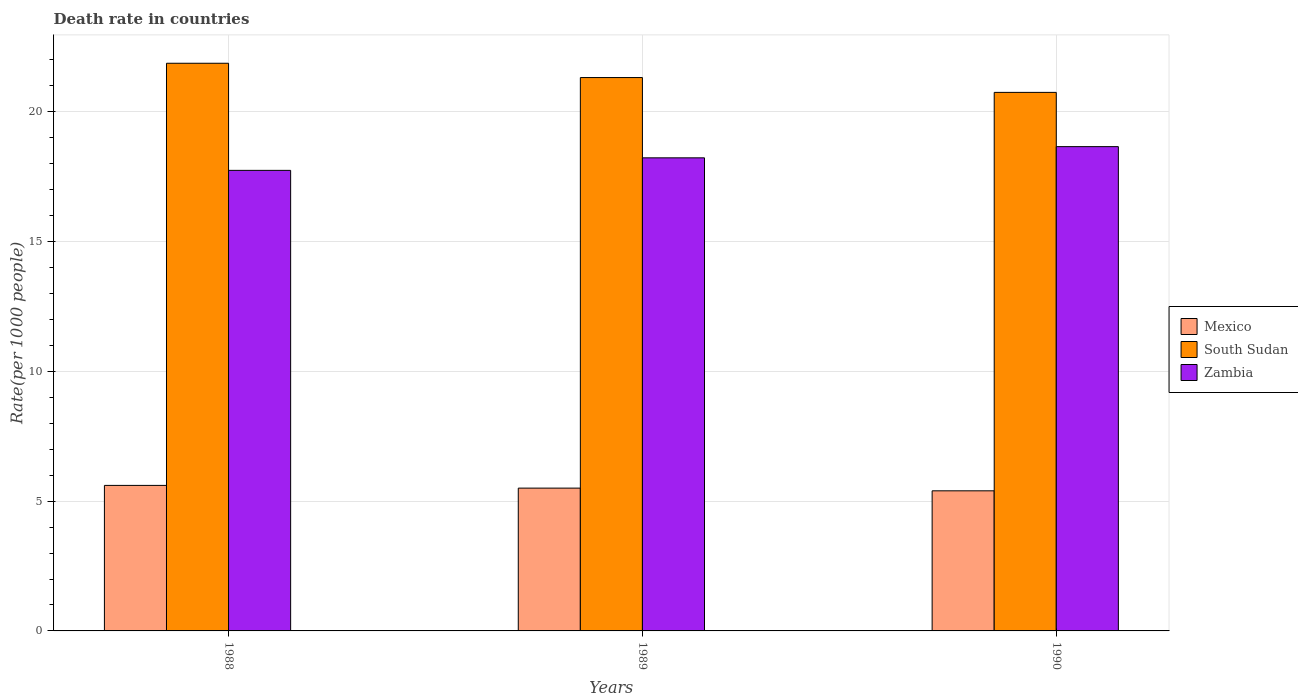Are the number of bars on each tick of the X-axis equal?
Your answer should be very brief. Yes. How many bars are there on the 3rd tick from the left?
Your answer should be compact. 3. What is the label of the 2nd group of bars from the left?
Provide a succinct answer. 1989. In how many cases, is the number of bars for a given year not equal to the number of legend labels?
Provide a succinct answer. 0. What is the death rate in South Sudan in 1990?
Give a very brief answer. 20.75. Across all years, what is the maximum death rate in Zambia?
Offer a terse response. 18.66. Across all years, what is the minimum death rate in Zambia?
Provide a succinct answer. 17.74. In which year was the death rate in Mexico minimum?
Provide a succinct answer. 1990. What is the total death rate in Mexico in the graph?
Offer a terse response. 16.51. What is the difference between the death rate in Zambia in 1988 and that in 1989?
Your response must be concise. -0.48. What is the difference between the death rate in Zambia in 1989 and the death rate in South Sudan in 1990?
Provide a short and direct response. -2.52. What is the average death rate in South Sudan per year?
Provide a succinct answer. 21.31. In the year 1989, what is the difference between the death rate in South Sudan and death rate in Mexico?
Your response must be concise. 15.82. What is the ratio of the death rate in South Sudan in 1988 to that in 1989?
Your answer should be very brief. 1.03. Is the death rate in South Sudan in 1989 less than that in 1990?
Offer a very short reply. No. Is the difference between the death rate in South Sudan in 1988 and 1990 greater than the difference between the death rate in Mexico in 1988 and 1990?
Make the answer very short. Yes. What is the difference between the highest and the second highest death rate in South Sudan?
Your answer should be compact. 0.55. What is the difference between the highest and the lowest death rate in Mexico?
Your answer should be compact. 0.21. In how many years, is the death rate in South Sudan greater than the average death rate in South Sudan taken over all years?
Keep it short and to the point. 2. Is the sum of the death rate in Zambia in 1988 and 1989 greater than the maximum death rate in Mexico across all years?
Keep it short and to the point. Yes. What does the 2nd bar from the left in 1988 represents?
Ensure brevity in your answer.  South Sudan. How many bars are there?
Provide a succinct answer. 9. How many years are there in the graph?
Make the answer very short. 3. What is the difference between two consecutive major ticks on the Y-axis?
Make the answer very short. 5. Does the graph contain any zero values?
Provide a succinct answer. No. Does the graph contain grids?
Keep it short and to the point. Yes. How many legend labels are there?
Provide a short and direct response. 3. How are the legend labels stacked?
Make the answer very short. Vertical. What is the title of the graph?
Provide a succinct answer. Death rate in countries. What is the label or title of the X-axis?
Offer a terse response. Years. What is the label or title of the Y-axis?
Give a very brief answer. Rate(per 1000 people). What is the Rate(per 1000 people) of Mexico in 1988?
Provide a short and direct response. 5.61. What is the Rate(per 1000 people) in South Sudan in 1988?
Provide a succinct answer. 21.87. What is the Rate(per 1000 people) of Zambia in 1988?
Provide a succinct answer. 17.74. What is the Rate(per 1000 people) in Mexico in 1989?
Give a very brief answer. 5.5. What is the Rate(per 1000 people) of South Sudan in 1989?
Offer a terse response. 21.32. What is the Rate(per 1000 people) in Zambia in 1989?
Your answer should be compact. 18.23. What is the Rate(per 1000 people) in Mexico in 1990?
Keep it short and to the point. 5.4. What is the Rate(per 1000 people) in South Sudan in 1990?
Your answer should be compact. 20.75. What is the Rate(per 1000 people) in Zambia in 1990?
Offer a terse response. 18.66. Across all years, what is the maximum Rate(per 1000 people) in Mexico?
Your answer should be compact. 5.61. Across all years, what is the maximum Rate(per 1000 people) in South Sudan?
Offer a very short reply. 21.87. Across all years, what is the maximum Rate(per 1000 people) in Zambia?
Give a very brief answer. 18.66. Across all years, what is the minimum Rate(per 1000 people) in Mexico?
Provide a succinct answer. 5.4. Across all years, what is the minimum Rate(per 1000 people) of South Sudan?
Provide a short and direct response. 20.75. Across all years, what is the minimum Rate(per 1000 people) in Zambia?
Offer a terse response. 17.74. What is the total Rate(per 1000 people) in Mexico in the graph?
Ensure brevity in your answer.  16.51. What is the total Rate(per 1000 people) in South Sudan in the graph?
Your answer should be compact. 63.94. What is the total Rate(per 1000 people) in Zambia in the graph?
Make the answer very short. 54.63. What is the difference between the Rate(per 1000 people) in Mexico in 1988 and that in 1989?
Your response must be concise. 0.1. What is the difference between the Rate(per 1000 people) in South Sudan in 1988 and that in 1989?
Keep it short and to the point. 0.55. What is the difference between the Rate(per 1000 people) of Zambia in 1988 and that in 1989?
Give a very brief answer. -0.48. What is the difference between the Rate(per 1000 people) in Mexico in 1988 and that in 1990?
Provide a short and direct response. 0.21. What is the difference between the Rate(per 1000 people) of South Sudan in 1988 and that in 1990?
Your answer should be very brief. 1.12. What is the difference between the Rate(per 1000 people) of Zambia in 1988 and that in 1990?
Your response must be concise. -0.92. What is the difference between the Rate(per 1000 people) in Mexico in 1989 and that in 1990?
Offer a terse response. 0.1. What is the difference between the Rate(per 1000 people) of South Sudan in 1989 and that in 1990?
Provide a succinct answer. 0.57. What is the difference between the Rate(per 1000 people) of Zambia in 1989 and that in 1990?
Offer a terse response. -0.43. What is the difference between the Rate(per 1000 people) in Mexico in 1988 and the Rate(per 1000 people) in South Sudan in 1989?
Your response must be concise. -15.71. What is the difference between the Rate(per 1000 people) of Mexico in 1988 and the Rate(per 1000 people) of Zambia in 1989?
Make the answer very short. -12.62. What is the difference between the Rate(per 1000 people) of South Sudan in 1988 and the Rate(per 1000 people) of Zambia in 1989?
Provide a short and direct response. 3.64. What is the difference between the Rate(per 1000 people) in Mexico in 1988 and the Rate(per 1000 people) in South Sudan in 1990?
Ensure brevity in your answer.  -15.14. What is the difference between the Rate(per 1000 people) in Mexico in 1988 and the Rate(per 1000 people) in Zambia in 1990?
Offer a terse response. -13.05. What is the difference between the Rate(per 1000 people) in South Sudan in 1988 and the Rate(per 1000 people) in Zambia in 1990?
Keep it short and to the point. 3.21. What is the difference between the Rate(per 1000 people) in Mexico in 1989 and the Rate(per 1000 people) in South Sudan in 1990?
Provide a succinct answer. -15.25. What is the difference between the Rate(per 1000 people) of Mexico in 1989 and the Rate(per 1000 people) of Zambia in 1990?
Give a very brief answer. -13.16. What is the difference between the Rate(per 1000 people) of South Sudan in 1989 and the Rate(per 1000 people) of Zambia in 1990?
Provide a succinct answer. 2.66. What is the average Rate(per 1000 people) in Mexico per year?
Offer a very short reply. 5.5. What is the average Rate(per 1000 people) of South Sudan per year?
Your answer should be very brief. 21.31. What is the average Rate(per 1000 people) of Zambia per year?
Give a very brief answer. 18.21. In the year 1988, what is the difference between the Rate(per 1000 people) in Mexico and Rate(per 1000 people) in South Sudan?
Give a very brief answer. -16.26. In the year 1988, what is the difference between the Rate(per 1000 people) of Mexico and Rate(per 1000 people) of Zambia?
Your answer should be compact. -12.14. In the year 1988, what is the difference between the Rate(per 1000 people) in South Sudan and Rate(per 1000 people) in Zambia?
Your response must be concise. 4.13. In the year 1989, what is the difference between the Rate(per 1000 people) in Mexico and Rate(per 1000 people) in South Sudan?
Give a very brief answer. -15.82. In the year 1989, what is the difference between the Rate(per 1000 people) in Mexico and Rate(per 1000 people) in Zambia?
Your response must be concise. -12.72. In the year 1989, what is the difference between the Rate(per 1000 people) in South Sudan and Rate(per 1000 people) in Zambia?
Your answer should be compact. 3.09. In the year 1990, what is the difference between the Rate(per 1000 people) of Mexico and Rate(per 1000 people) of South Sudan?
Keep it short and to the point. -15.35. In the year 1990, what is the difference between the Rate(per 1000 people) of Mexico and Rate(per 1000 people) of Zambia?
Offer a terse response. -13.26. In the year 1990, what is the difference between the Rate(per 1000 people) of South Sudan and Rate(per 1000 people) of Zambia?
Make the answer very short. 2.09. What is the ratio of the Rate(per 1000 people) of Mexico in 1988 to that in 1989?
Make the answer very short. 1.02. What is the ratio of the Rate(per 1000 people) in South Sudan in 1988 to that in 1989?
Keep it short and to the point. 1.03. What is the ratio of the Rate(per 1000 people) in Zambia in 1988 to that in 1989?
Your response must be concise. 0.97. What is the ratio of the Rate(per 1000 people) of Mexico in 1988 to that in 1990?
Provide a short and direct response. 1.04. What is the ratio of the Rate(per 1000 people) of South Sudan in 1988 to that in 1990?
Provide a succinct answer. 1.05. What is the ratio of the Rate(per 1000 people) of Zambia in 1988 to that in 1990?
Give a very brief answer. 0.95. What is the ratio of the Rate(per 1000 people) in Mexico in 1989 to that in 1990?
Your answer should be compact. 1.02. What is the ratio of the Rate(per 1000 people) in South Sudan in 1989 to that in 1990?
Keep it short and to the point. 1.03. What is the ratio of the Rate(per 1000 people) in Zambia in 1989 to that in 1990?
Make the answer very short. 0.98. What is the difference between the highest and the second highest Rate(per 1000 people) in Mexico?
Ensure brevity in your answer.  0.1. What is the difference between the highest and the second highest Rate(per 1000 people) of South Sudan?
Give a very brief answer. 0.55. What is the difference between the highest and the second highest Rate(per 1000 people) of Zambia?
Offer a very short reply. 0.43. What is the difference between the highest and the lowest Rate(per 1000 people) of Mexico?
Provide a succinct answer. 0.21. What is the difference between the highest and the lowest Rate(per 1000 people) of South Sudan?
Provide a short and direct response. 1.12. What is the difference between the highest and the lowest Rate(per 1000 people) of Zambia?
Give a very brief answer. 0.92. 